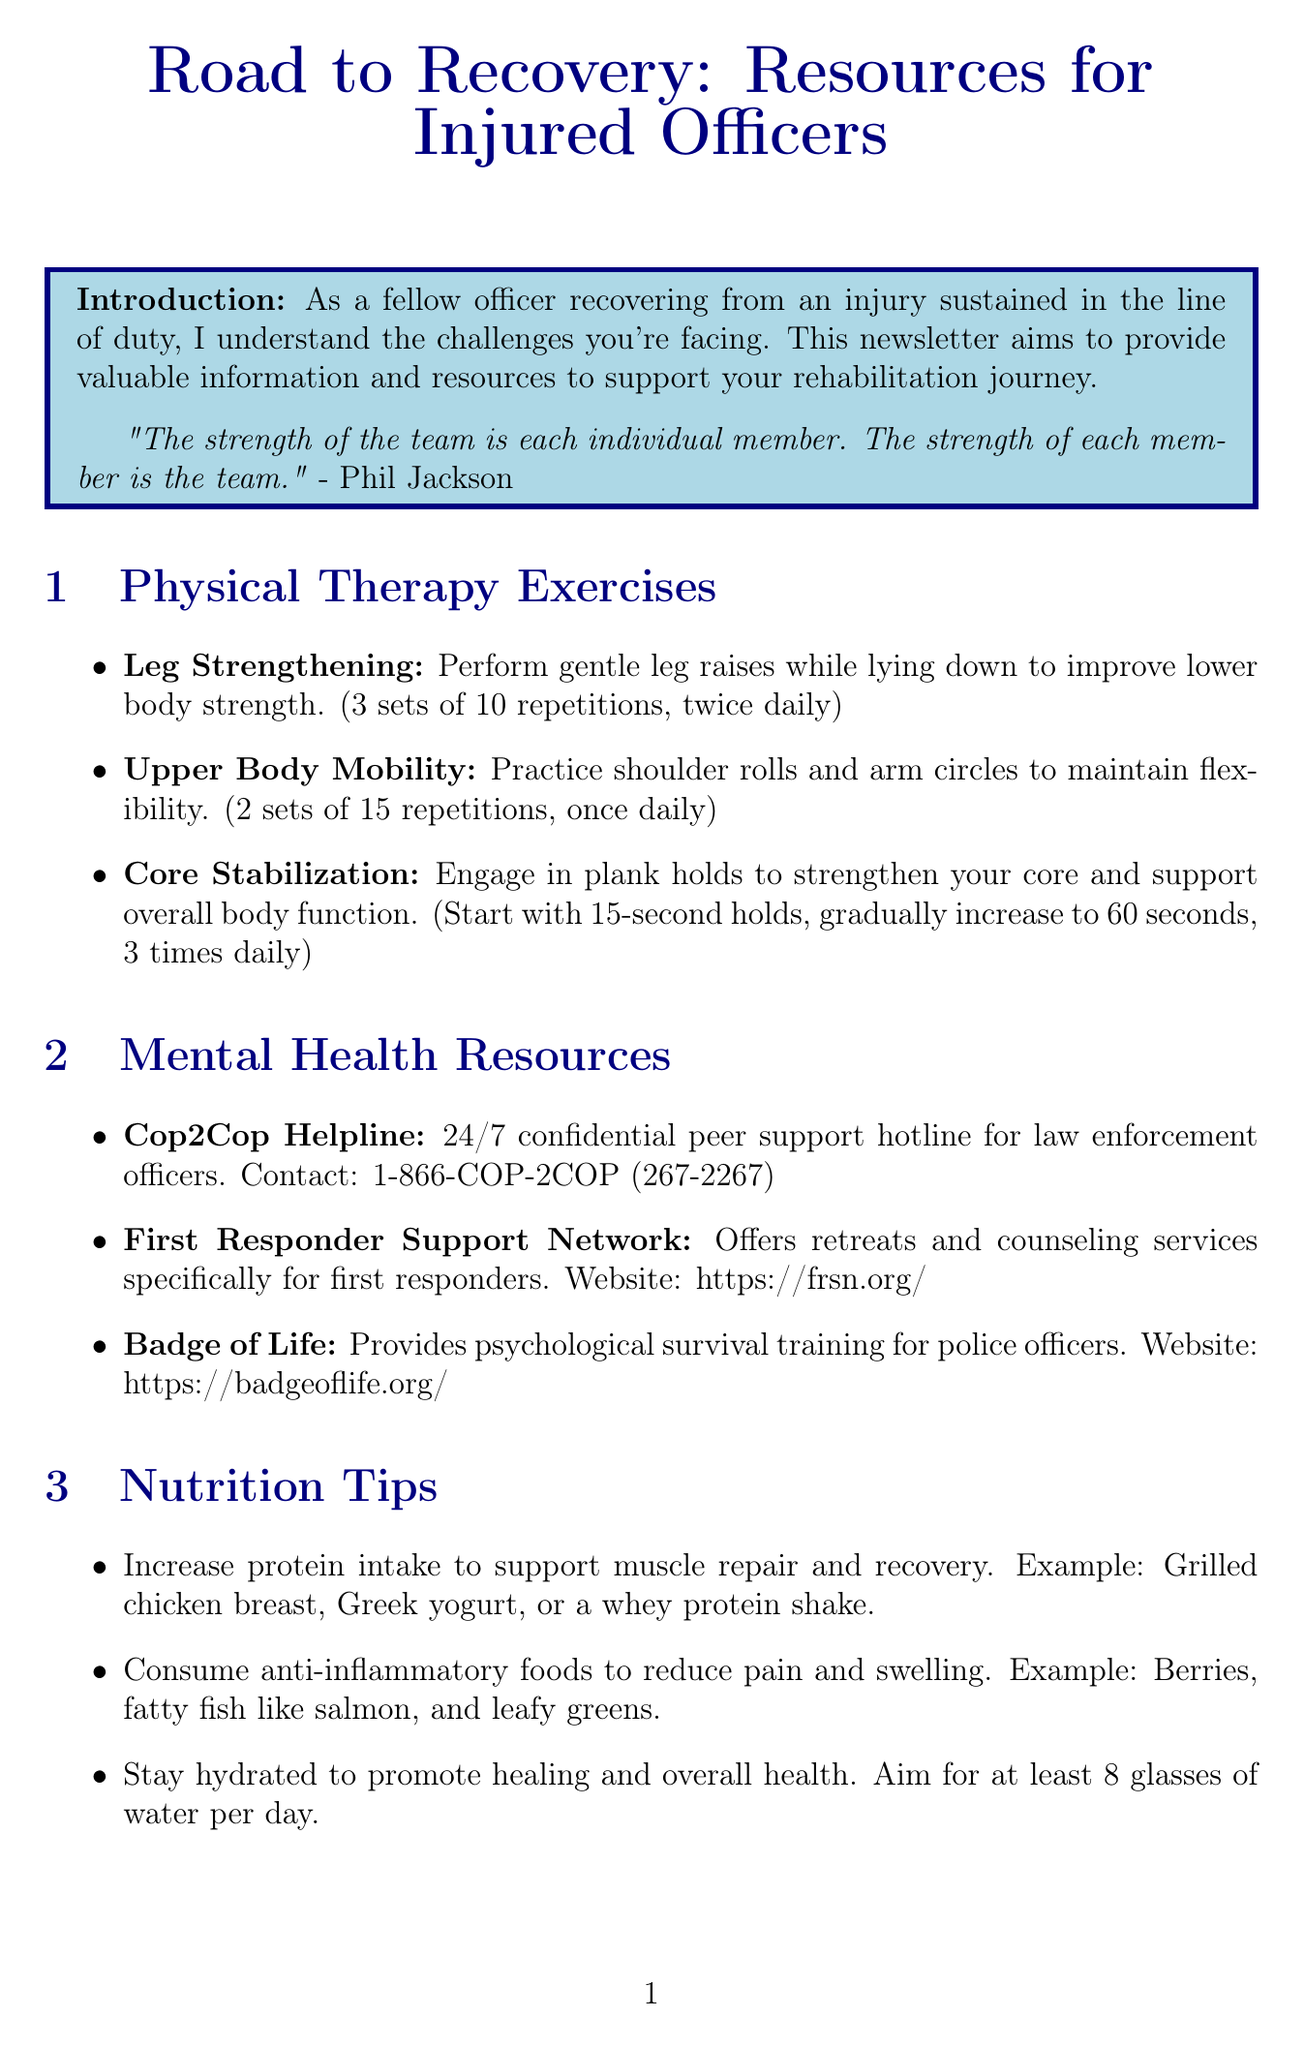what is the title of the newsletter? The title of the newsletter is provided at the beginning of the document.
Answer: Road to Recovery: Resources for Injured Officers how many sets of leg raises should be performed daily? The physical therapy exercises section specifies the number of sets and repetitions for leg raises.
Answer: 3 sets of 10 repetitions, twice daily what is the contact number for the Cop2Cop Helpline? The mental health resources section includes the contact number for the Cop2Cop Helpline.
Answer: 1-866-COP-2COP (267-2267) which organization provides psychological survival training? The mental health resources section lists different organizations and their services, including training.
Answer: Badge of Life what is one nutrition tip mentioned in the newsletter? The nutrition tips section offers various tips to support recovery and nutrition.
Answer: Increase protein intake to support muscle repair and recovery how does Officer Mario Gutierrez's story contribute to the newsletter? The inspirational story section highlights personal experiences to motivate and encourage readers in their recovery journey.
Answer: A story of resilience what is a recommended resource for returning to work? The returning to work section suggests resources for officers as they transition back into their roles.
Answer: IACP Center for Officer Safety and Wellness what is one way to support mental health for officers? The mental health resources section offers different options to support mental wellness among officers.
Answer: Cop2Cop Helpline how often should plank holds be performed? The physical therapy exercises section details how frequently plank holds should occur.
Answer: 3 times daily 